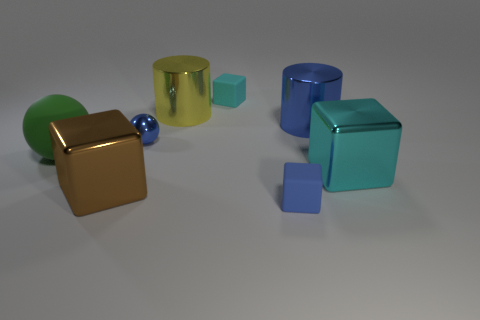Subtract all red blocks. Subtract all yellow cylinders. How many blocks are left? 4 Add 2 tiny cyan spheres. How many objects exist? 10 Subtract all cylinders. How many objects are left? 6 Add 4 blue cubes. How many blue cubes are left? 5 Add 4 big blue objects. How many big blue objects exist? 5 Subtract 1 blue cylinders. How many objects are left? 7 Subtract all large green cubes. Subtract all large green things. How many objects are left? 7 